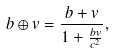<formula> <loc_0><loc_0><loc_500><loc_500>b \oplus v = \frac { b + v } { 1 + \frac { { b } { v } } { c ^ { 2 } } } ,</formula> 